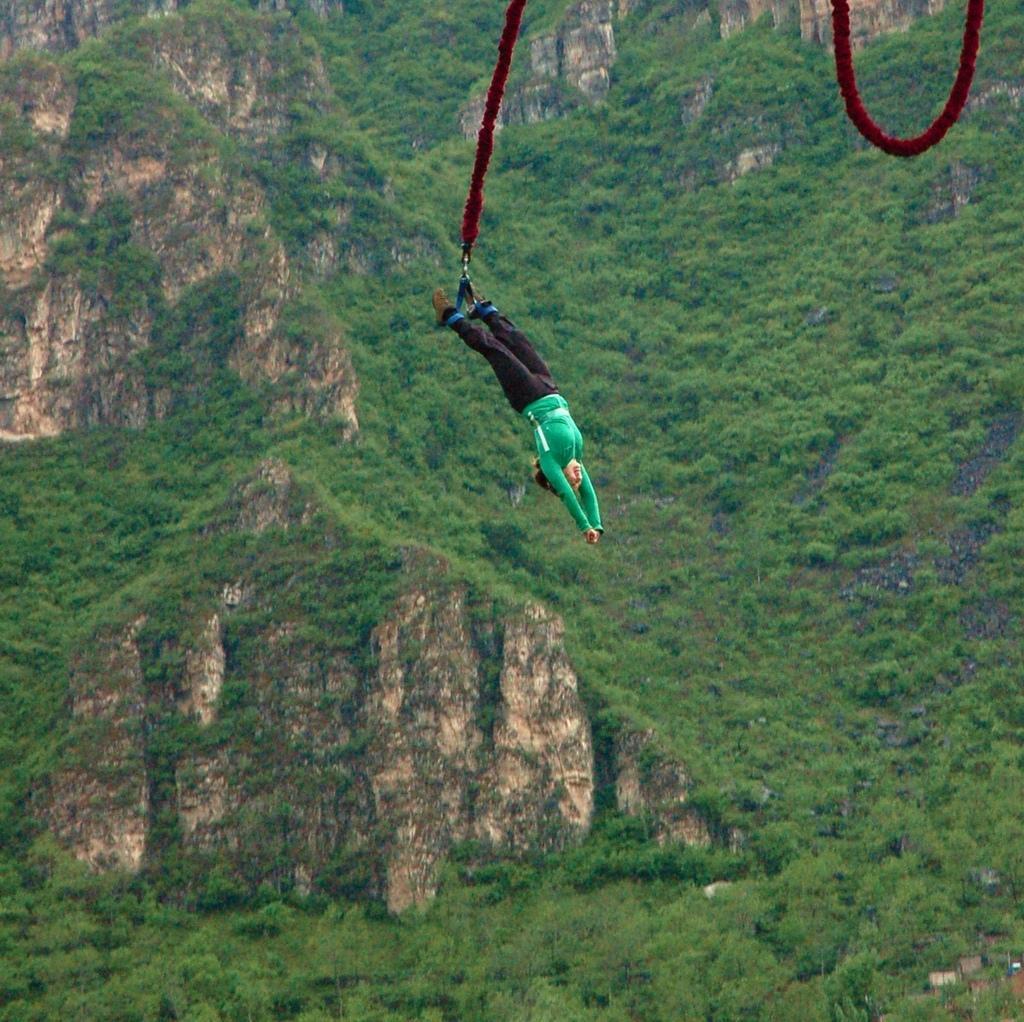Describe this image in one or two sentences. In the image there is a person performing bungee jumping, behind the person there is a huge mountain in the background. 